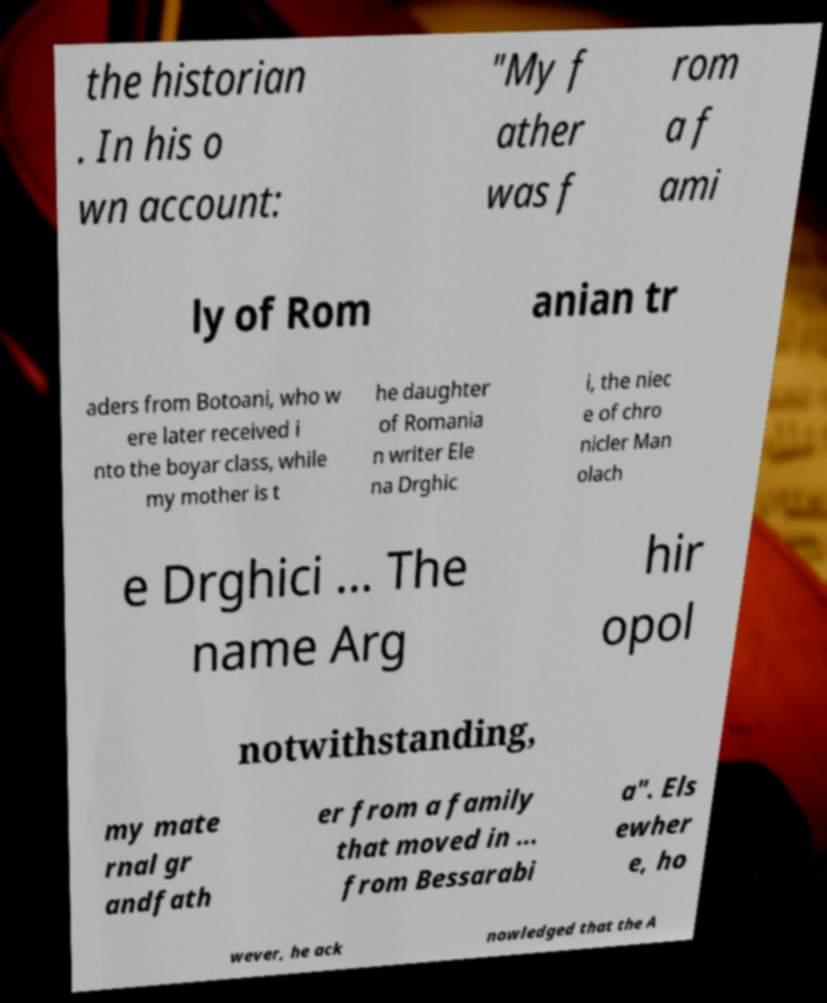Could you assist in decoding the text presented in this image and type it out clearly? the historian . In his o wn account: "My f ather was f rom a f ami ly of Rom anian tr aders from Botoani, who w ere later received i nto the boyar class, while my mother is t he daughter of Romania n writer Ele na Drghic i, the niec e of chro nicler Man olach e Drghici ... The name Arg hir opol notwithstanding, my mate rnal gr andfath er from a family that moved in ... from Bessarabi a". Els ewher e, ho wever, he ack nowledged that the A 